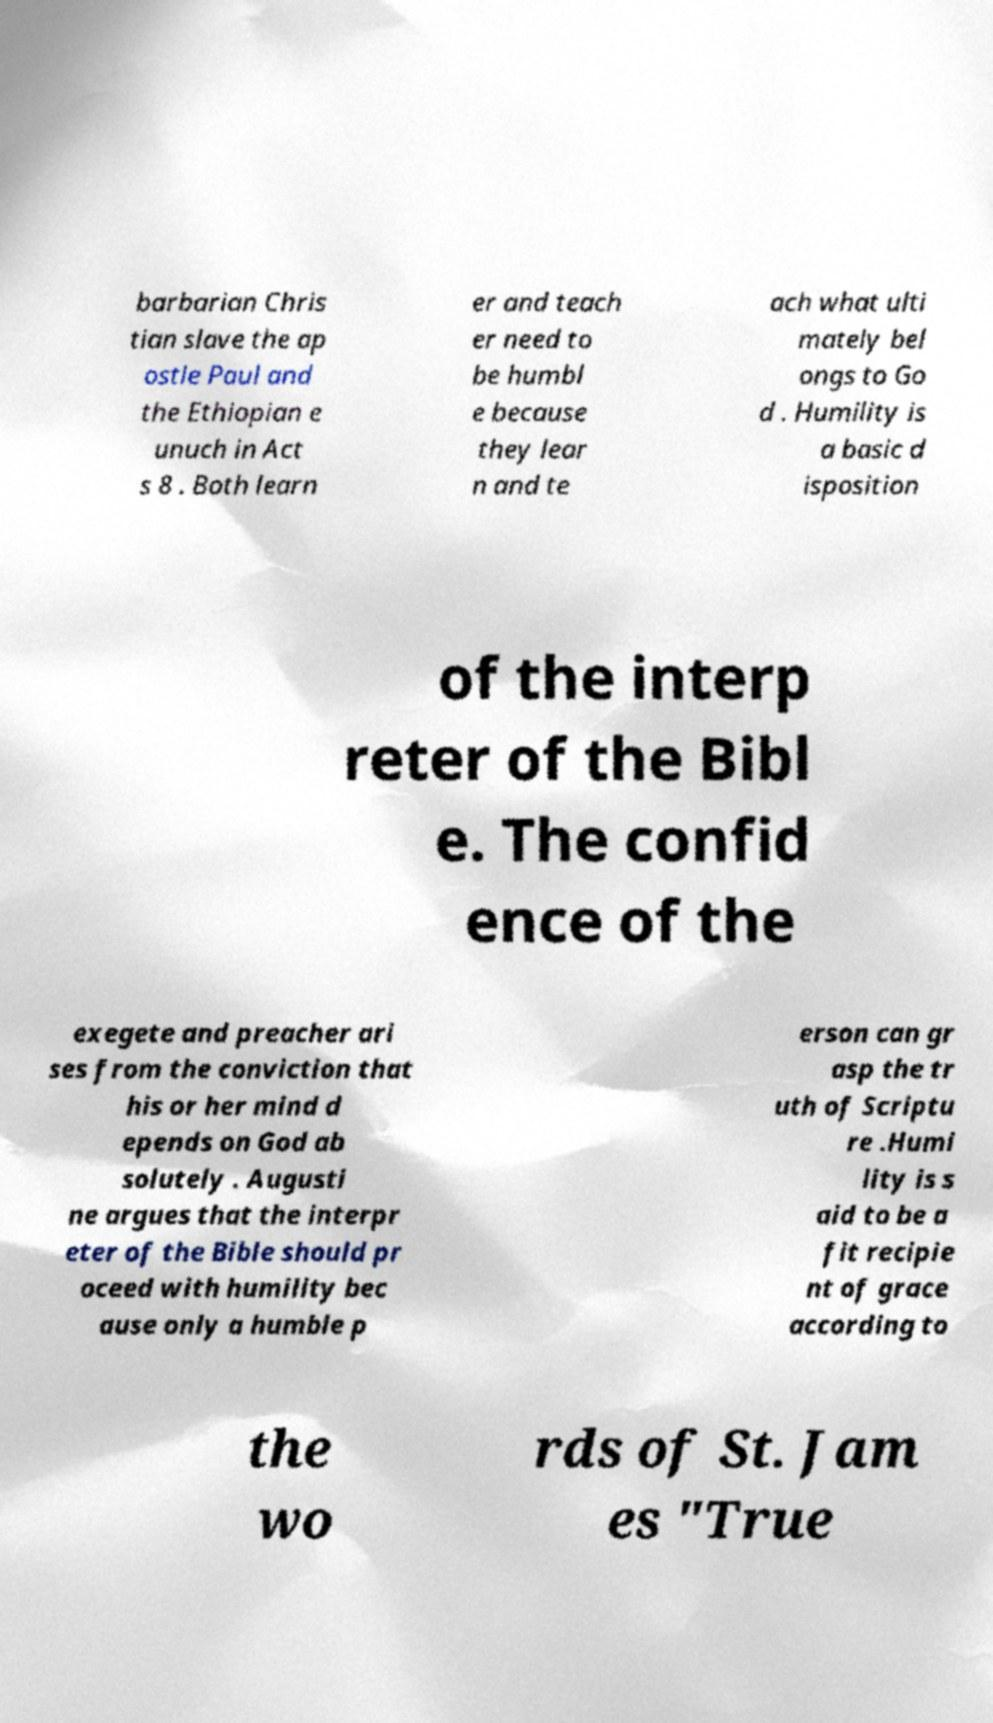There's text embedded in this image that I need extracted. Can you transcribe it verbatim? barbarian Chris tian slave the ap ostle Paul and the Ethiopian e unuch in Act s 8 . Both learn er and teach er need to be humbl e because they lear n and te ach what ulti mately bel ongs to Go d . Humility is a basic d isposition of the interp reter of the Bibl e. The confid ence of the exegete and preacher ari ses from the conviction that his or her mind d epends on God ab solutely . Augusti ne argues that the interpr eter of the Bible should pr oceed with humility bec ause only a humble p erson can gr asp the tr uth of Scriptu re .Humi lity is s aid to be a fit recipie nt of grace according to the wo rds of St. Jam es "True 